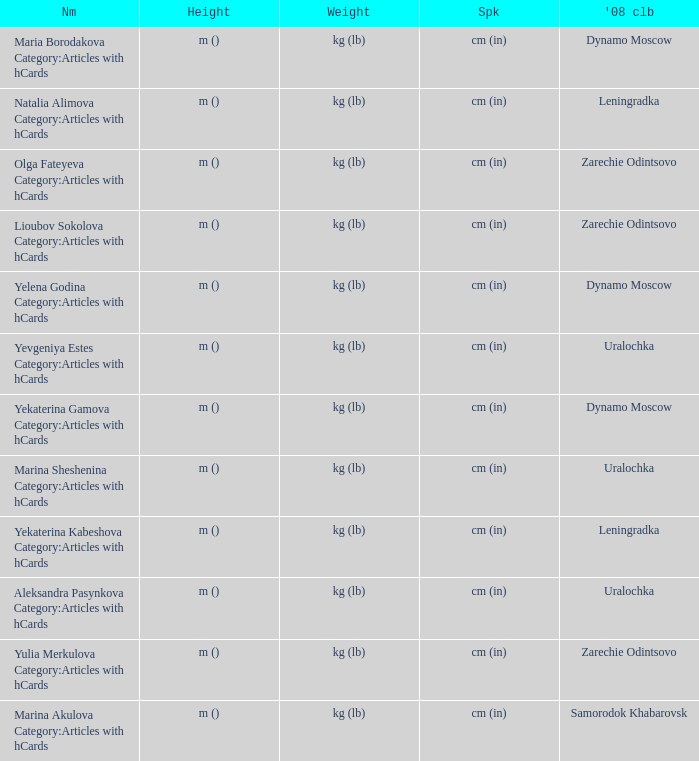What is the name when the 2008 club is uralochka? Yevgeniya Estes Category:Articles with hCards, Marina Sheshenina Category:Articles with hCards, Aleksandra Pasynkova Category:Articles with hCards. 